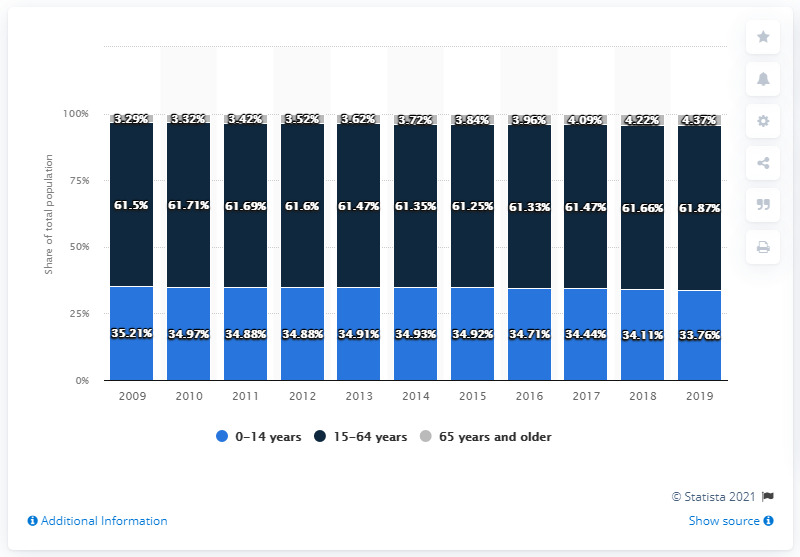Indicate a few pertinent items in this graphic. The difference in the maximum population of people with age group 15-64 over the years and the minimum population of people with age group 0-14 over the years is 28.11%. The population of individuals in the age group of 0-14 years was highest in 2009 among all the years considered. 